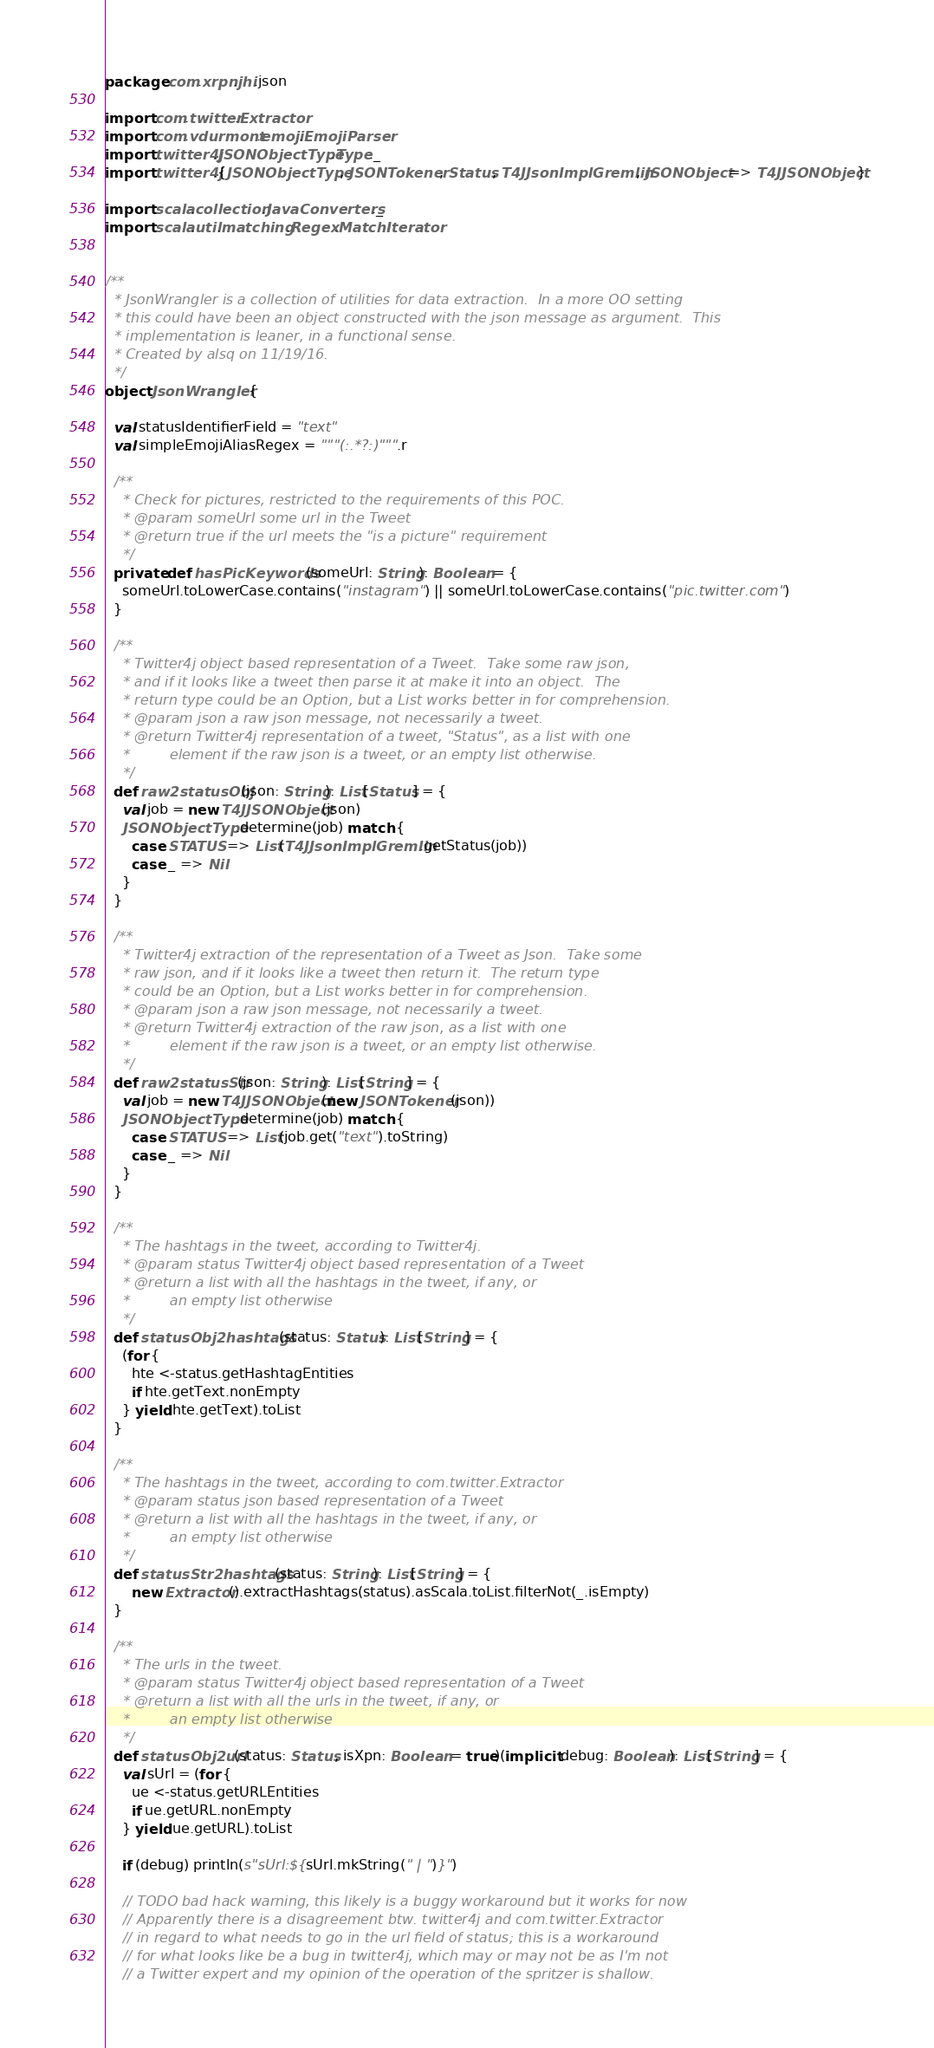<code> <loc_0><loc_0><loc_500><loc_500><_Scala_>package com.xrpn.jhi.json

import com.twitter.Extractor
import com.vdurmont.emoji.EmojiParser
import twitter4j.JSONObjectType.Type._
import twitter4j.{JSONObjectType, JSONTokener, Status, T4JJsonImplGremlin, JSONObject => T4JJSONObject}

import scala.collection.JavaConverters._
import scala.util.matching.Regex.MatchIterator


/**
  * JsonWrangler is a collection of utilities for data extraction.  In a more OO setting
  * this could have been an object constructed with the json message as argument.  This
  * implementation is leaner, in a functional sense.
  * Created by alsq on 11/19/16.
  */
object JsonWrangler {

  val statusIdentifierField = "text"
  val simpleEmojiAliasRegex = """(:.*?:)""".r

  /**
    * Check for pictures, restricted to the requirements of this POC.
    * @param someUrl some url in the Tweet
    * @return true if the url meets the "is a picture" requirement
    */
  private def hasPicKeywords(someUrl: String): Boolean = {
    someUrl.toLowerCase.contains("instagram") || someUrl.toLowerCase.contains("pic.twitter.com")
  }

  /**
    * Twitter4j object based representation of a Tweet.  Take some raw json,
    * and if it looks like a tweet then parse it at make it into an object.  The
    * return type could be an Option, but a List works better in for comprehension.
    * @param json a raw json message, not necessarily a tweet.
    * @return Twitter4j representation of a tweet, "Status", as a list with one
    *         element if the raw json is a tweet, or an empty list otherwise.
    */
  def raw2statusObj(json: String): List[Status] = {
    val job = new T4JJSONObject(json)
    JSONObjectType.determine(job) match {
      case STATUS => List(T4JJsonImplGremlin.getStatus(job))
      case _ => Nil
    }
  }

  /**
    * Twitter4j extraction of the representation of a Tweet as Json.  Take some
    * raw json, and if it looks like a tweet then return it.  The return type
    * could be an Option, but a List works better in for comprehension.
    * @param json a raw json message, not necessarily a tweet.
    * @return Twitter4j extraction of the raw json, as a list with one
    *         element if the raw json is a tweet, or an empty list otherwise.
    */
  def raw2statusStr(json: String): List[String] = {
    val job = new T4JJSONObject(new JSONTokener(json))
    JSONObjectType.determine(job) match {
      case STATUS => List(job.get("text").toString)
      case _ => Nil
    }
  }

  /**
    * The hashtags in the tweet, according to Twitter4j.
    * @param status Twitter4j object based representation of a Tweet
    * @return a list with all the hashtags in the tweet, if any, or
    *         an empty list otherwise
    */
  def statusObj2hashtags(status: Status): List[String] = {
    (for {
      hte <-status.getHashtagEntities
      if hte.getText.nonEmpty
    } yield hte.getText).toList
  }

  /**
    * The hashtags in the tweet, according to com.twitter.Extractor
    * @param status json based representation of a Tweet
    * @return a list with all the hashtags in the tweet, if any, or
    *         an empty list otherwise
    */
  def statusStr2hashtags(status: String): List[String] = {
      new Extractor().extractHashtags(status).asScala.toList.filterNot(_.isEmpty)
  }

  /**
    * The urls in the tweet.
    * @param status Twitter4j object based representation of a Tweet
    * @return a list with all the urls in the tweet, if any, or
    *         an empty list otherwise
    */
  def statusObj2url(status: Status, isXpn: Boolean = true)(implicit debug: Boolean): List[String] = {
    val sUrl = (for {
      ue <-status.getURLEntities
      if ue.getURL.nonEmpty
    } yield ue.getURL).toList

    if (debug) println(s"sUrl:${sUrl.mkString(" | ")}")

    // TODO bad hack warning, this likely is a buggy workaround but it works for now
    // Apparently there is a disagreement btw. twitter4j and com.twitter.Extractor
    // in regard to what needs to go in the url field of status; this is a workaround
    // for what looks like be a bug in twitter4j, which may or may not be as I'm not
    // a Twitter expert and my opinion of the operation of the spritzer is shallow.</code> 